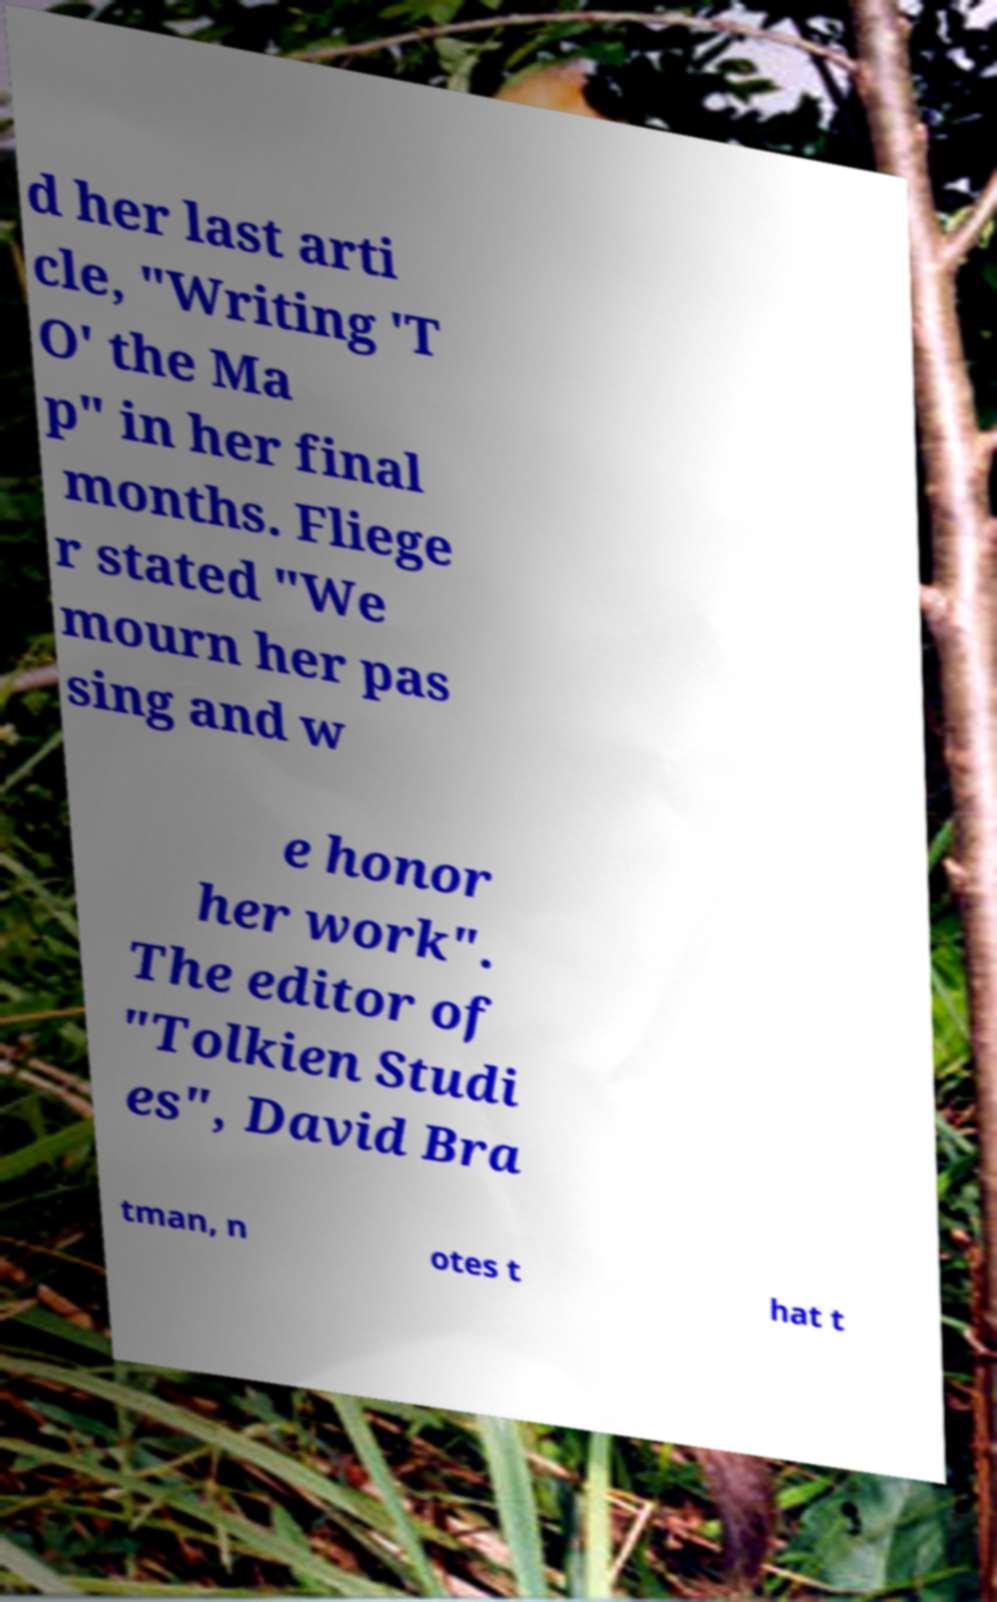Can you accurately transcribe the text from the provided image for me? d her last arti cle, "Writing 'T O' the Ma p" in her final months. Fliege r stated "We mourn her pas sing and w e honor her work". The editor of "Tolkien Studi es", David Bra tman, n otes t hat t 